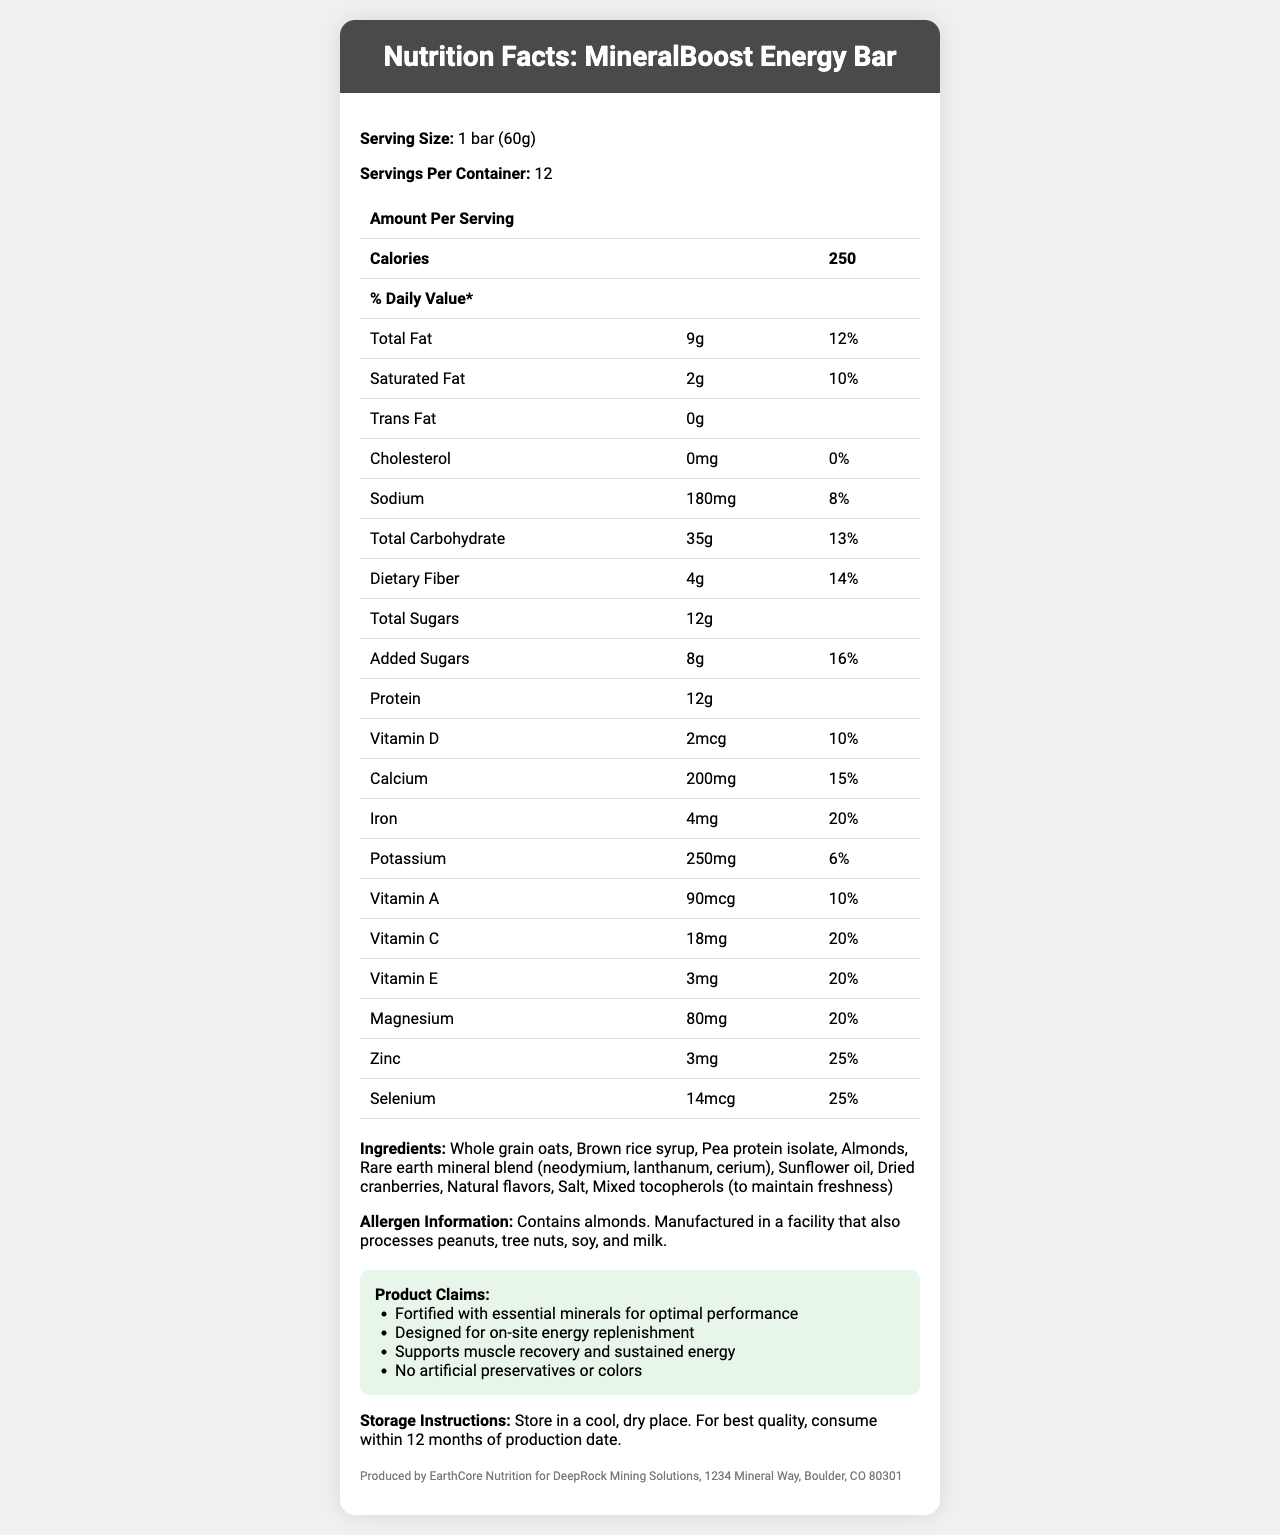what is the serving size for the MineralBoost Energy Bar? The document states that the serving size is 1 bar (60g).
Answer: 1 bar (60g) how many servings are in one container of MineralBoost Energy Bar? The document lists 12 servings per container.
Answer: 12 how many calories are there in one serving of MineralBoost Energy Bar? The document lists the calories per serving as 250.
Answer: 250 calories what is the total amount of fat in one serving of MineralBoost Energy Bar? The document states that the total fat per serving is 9g.
Answer: 9g what percentage of the daily value is the dietary fiber in one serving? The document states that the daily value percentage for dietary fiber is 14%.
Answer: 14% how much protein does one serving of MineralBoost Energy Bar contain? The document lists the protein content per serving as 12g.
Answer: 12g how much added sugars are there in one serving, and what is its % daily value? The document states that added sugars amount to 8g per serving and contribute 16% of the daily value.
Answer: 8g, 16% what is the amount of iron in one serving and its daily value percentage? According to the document, one serving contains 4mg of iron, which is 20% of the daily value.
Answer: 4mg, 20% does MineralBoost Energy Bar contain any trans fat? The document states that there is 0g of trans fat.
Answer: No what is the vitamin E content per serving in MineralBoost Energy Bar? The document lists the vitamin E content as 3mg.
Answer: 3mg which claim is made about the MineralBoost Energy Bar? A. Contains artificial preservatives B. Supports muscle recovery C. Low in sugar One of the claim statements in the document is "Supports muscle recovery and sustained energy."
Answer: B. Supports muscle recovery which mineral is NOT listed as part of the rare earth mineral blend in the ingredients? I. Neodymium II. Lanthanum III. Europium IV. Cerium The document lists neodymium, lanthanum, and cerium as part of the rare earth mineral blend but not europium.
Answer: III. Europium is there any cholesterol in the MineralBoost Energy Bar? The document states that the amount of cholesterol is 0mg.
Answer: No does the product contain almonds? If yes, what additional allergen warnings are provided? The document states that the product contains almonds and provides an allergen warning about peanuts, tree nuts, soy, and milk.
Answer: Yes, contains almonds. Manufactured in a facility that also processes peanuts, tree nuts, soy, and milk. can you store the MineralBoost Energy Bar anywhere? The document provides specific storage instructions: "Store in a cool, dry place."
Answer: No where is the MineralBoost Energy Bar manufactured? This information is provided at the end of the document under manufacturer info.
Answer: EarthCore Nutrition for DeepRock Mining Solutions, 1234 Mineral Way, Boulder, CO 80301 summarize the main idea of the document The document comprehensively displays all nutritional and product information for the MineralBoost Energy Bar, highlighting its benefits and manufacturing details.
Answer: The document details the nutritional facts, ingredients, allergen information, product claims, storage instructions, and manufacturer details of the MineralBoost Energy Bar. The bar is designed for energy replenishment and fortified with essential minerals, supporting muscle recovery, and free of artificial preservatives. what are the sales statistics for the MineralBoost Energy Bar? The document does not provide any sales information.
Answer: Cannot be determined 